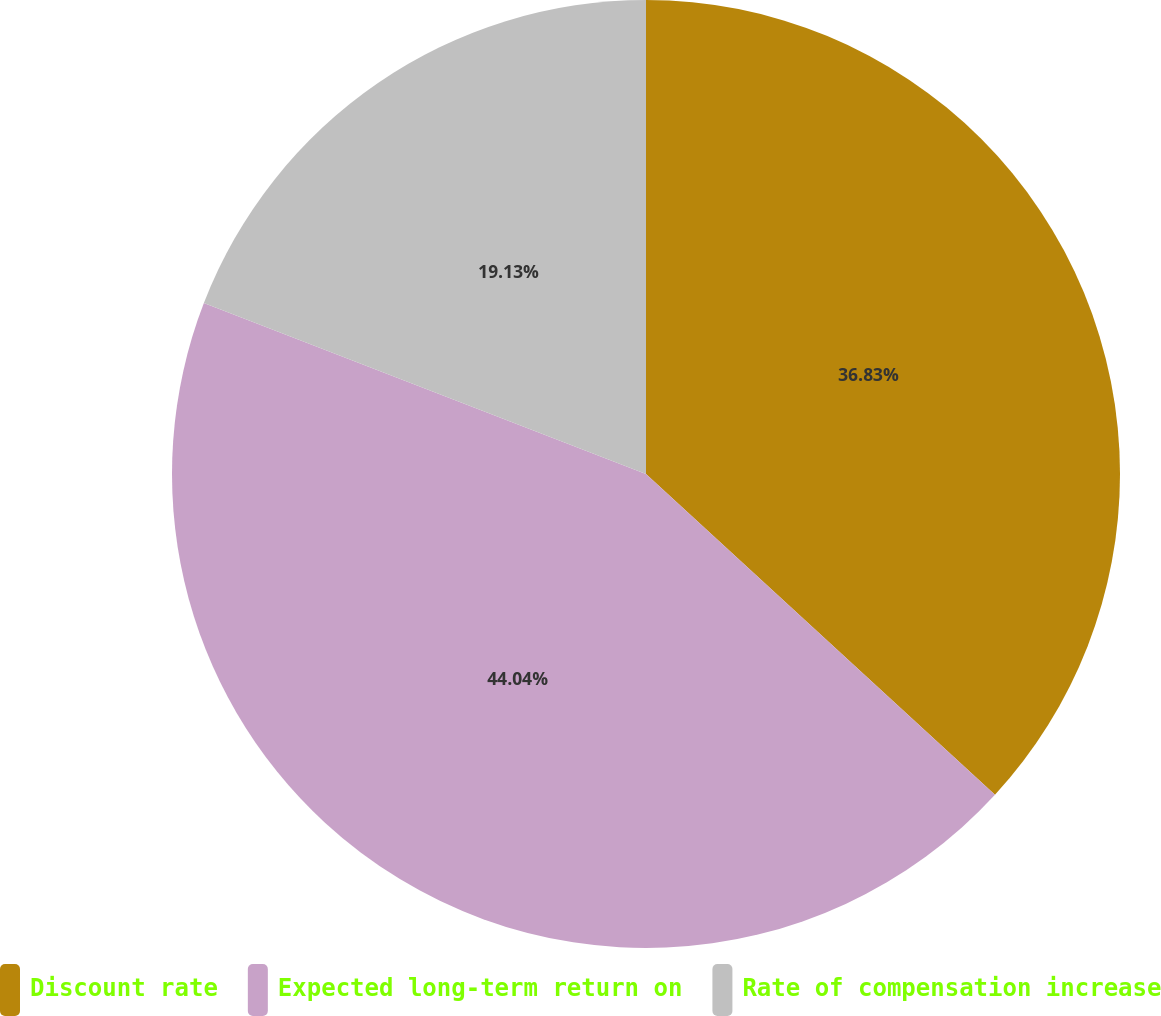Convert chart to OTSL. <chart><loc_0><loc_0><loc_500><loc_500><pie_chart><fcel>Discount rate<fcel>Expected long-term return on<fcel>Rate of compensation increase<nl><fcel>36.83%<fcel>44.04%<fcel>19.13%<nl></chart> 